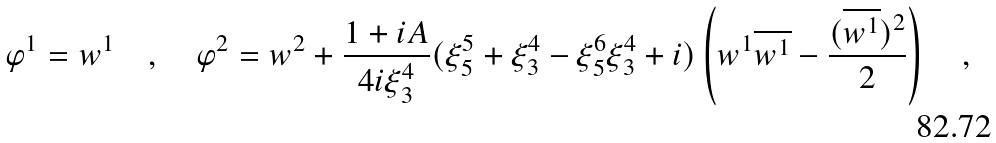<formula> <loc_0><loc_0><loc_500><loc_500>\varphi ^ { 1 } = w ^ { 1 } \quad , \quad \varphi ^ { 2 } = w ^ { 2 } + \frac { 1 + i A } { 4 i \xi ^ { 4 } _ { 3 } } ( \xi ^ { 5 } _ { 5 } + \xi ^ { 4 } _ { 3 } - \xi ^ { 6 } _ { 5 } \xi ^ { 4 } _ { 3 } + i ) \left ( w ^ { 1 } \overline { w ^ { 1 } } - \frac { ( \overline { w ^ { 1 } } ) ^ { 2 } } { 2 } \right ) \quad ,</formula> 